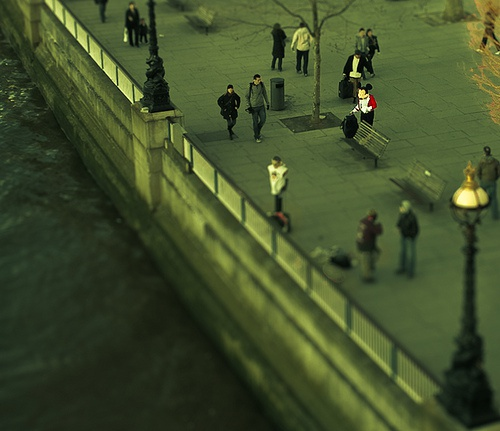Describe the objects in this image and their specific colors. I can see bench in black, darkgreen, and olive tones, people in black, darkgreen, and olive tones, people in black, darkgreen, and maroon tones, bench in black, darkgreen, and olive tones, and people in black, darkgreen, and green tones in this image. 